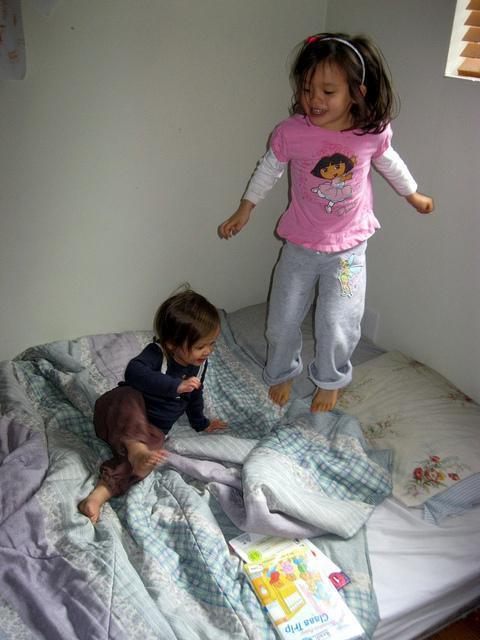How many girls are jumping on the bed?
Give a very brief answer. 1. How many people are there?
Give a very brief answer. 2. How many books can be seen?
Give a very brief answer. 2. 